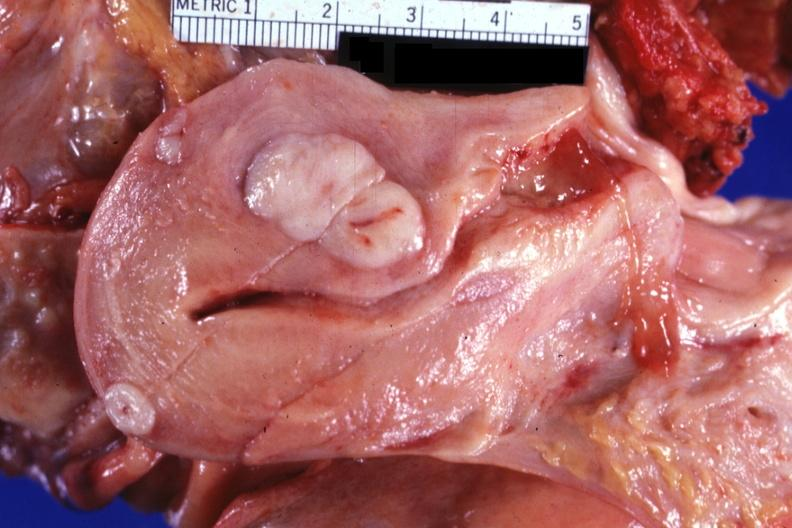s stillborn macerated present?
Answer the question using a single word or phrase. No 